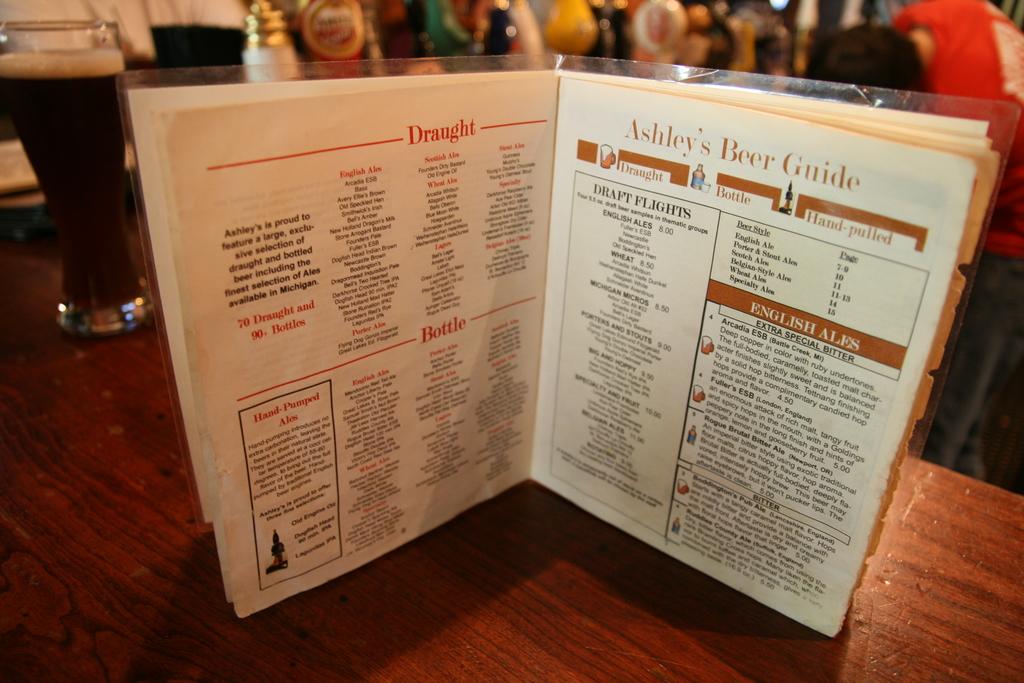What is this guide for?
Provide a succinct answer. Beer. What's the word very top left page?
Make the answer very short. Draught. 